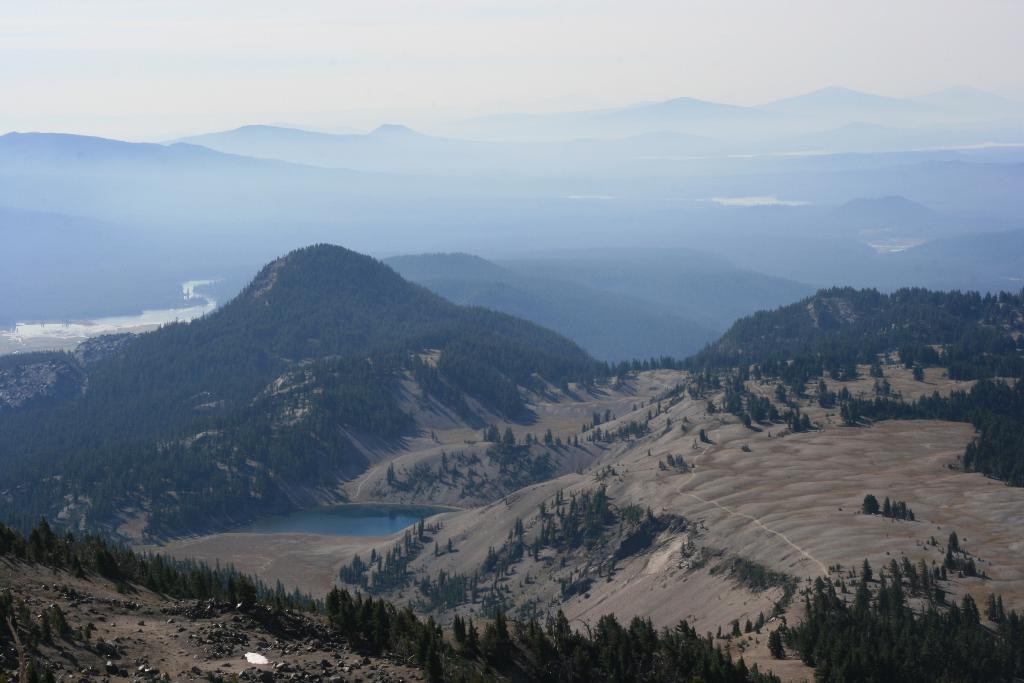What type of vegetation can be seen in the image? There are trees in the image. What can be found on the ground in the image? There are stones on the ground in the image. What is visible in the background of the image? There are trees, hills, water, mountains, and clouds in the background of the image. How many chairs are placed around the table in the image? There is no table or chairs present in the image. What type of nut is being cracked open by the squirrel in the image? There is no squirrel or nut present in the image. 